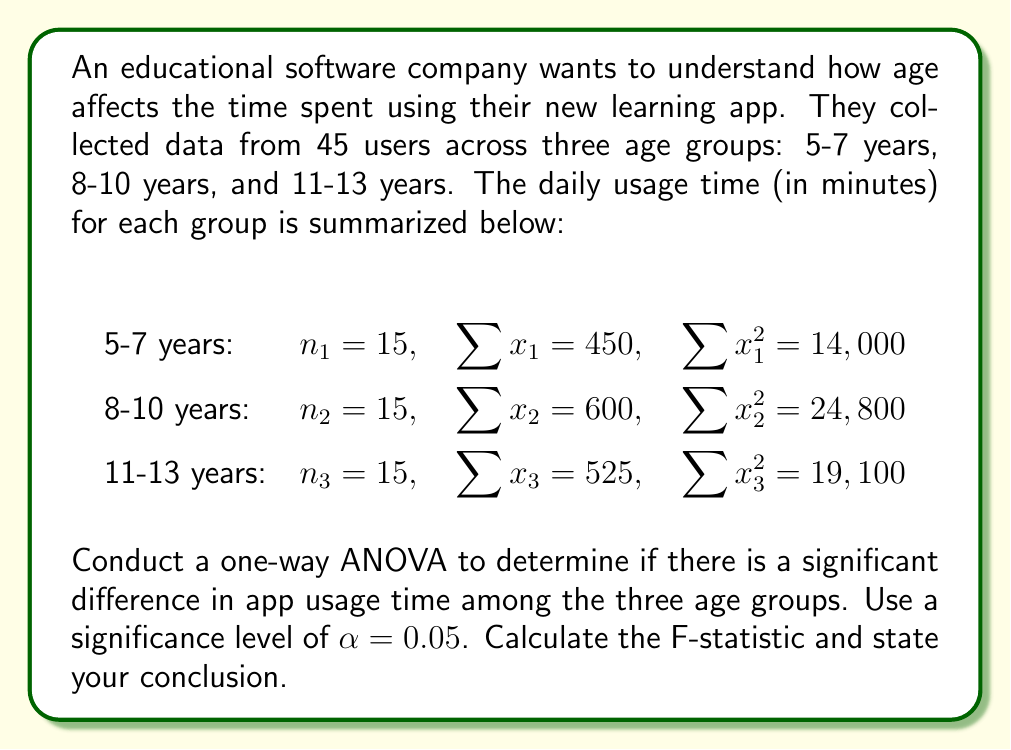Show me your answer to this math problem. To conduct a one-way ANOVA, we'll follow these steps:

1. Calculate the total sum of squares (SST):
   $$SST = \sum_{i=1}^k \sum_{j=1}^{n_i} x_{ij}^2 - \frac{(\sum_{i=1}^k \sum_{j=1}^{n_i} x_{ij})^2}{N}$$
   
   Where $k$ is the number of groups and $N$ is the total number of observations.

   $$SST = (14000 + 24800 + 19100) - \frac{(450 + 600 + 525)^2}{45} = 57900 - \frac{1575^2}{45} = 1566.67$$

2. Calculate the between-group sum of squares (SSB):
   $$SSB = \sum_{i=1}^k \frac{(\sum_{j=1}^{n_i} x_{ij})^2}{n_i} - \frac{(\sum_{i=1}^k \sum_{j=1}^{n_i} x_{ij})^2}{N}$$

   $$SSB = \frac{450^2}{15} + \frac{600^2}{15} + \frac{525^2}{15} - \frac{1575^2}{45} = 56825 - 55333.33 = 1491.67$$

3. Calculate the within-group sum of squares (SSW):
   $$SSW = SST - SSB = 1566.67 - 1491.67 = 75$$

4. Calculate the degrees of freedom:
   - Between groups: $df_B = k - 1 = 3 - 1 = 2$
   - Within groups: $df_W = N - k = 45 - 3 = 42$
   - Total: $df_T = N - 1 = 45 - 1 = 44$

5. Calculate the mean squares:
   - Between groups: $MS_B = \frac{SSB}{df_B} = \frac{1491.67}{2} = 745.835$
   - Within groups: $MS_W = \frac{SSW}{df_W} = \frac{75}{42} = 1.786$

6. Calculate the F-statistic:
   $$F = \frac{MS_B}{MS_W} = \frac{745.835}{1.786} = 417.60$$

7. Find the critical F-value:
   For $\alpha = 0.05$, $df_B = 2$, and $df_W = 42$, the critical F-value is approximately 3.22.

8. Compare the F-statistic to the critical F-value:
   Since $417.60 > 3.22$, we reject the null hypothesis.

Conclusion: There is strong evidence to suggest that there is a significant difference in app usage time among the three age groups (F(2, 42) = 417.60, p < 0.05).
Answer: F-statistic = 417.60

Conclusion: Reject the null hypothesis. There is a significant difference in app usage time among the three age groups (F(2, 42) = 417.60, p < 0.05). 